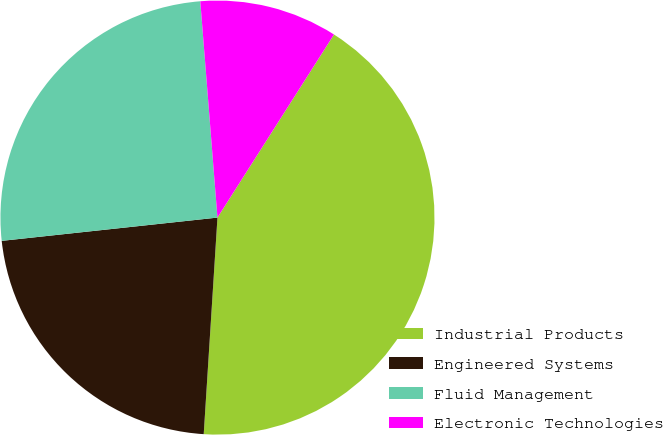Convert chart. <chart><loc_0><loc_0><loc_500><loc_500><pie_chart><fcel>Industrial Products<fcel>Engineered Systems<fcel>Fluid Management<fcel>Electronic Technologies<nl><fcel>41.99%<fcel>22.28%<fcel>25.45%<fcel>10.28%<nl></chart> 